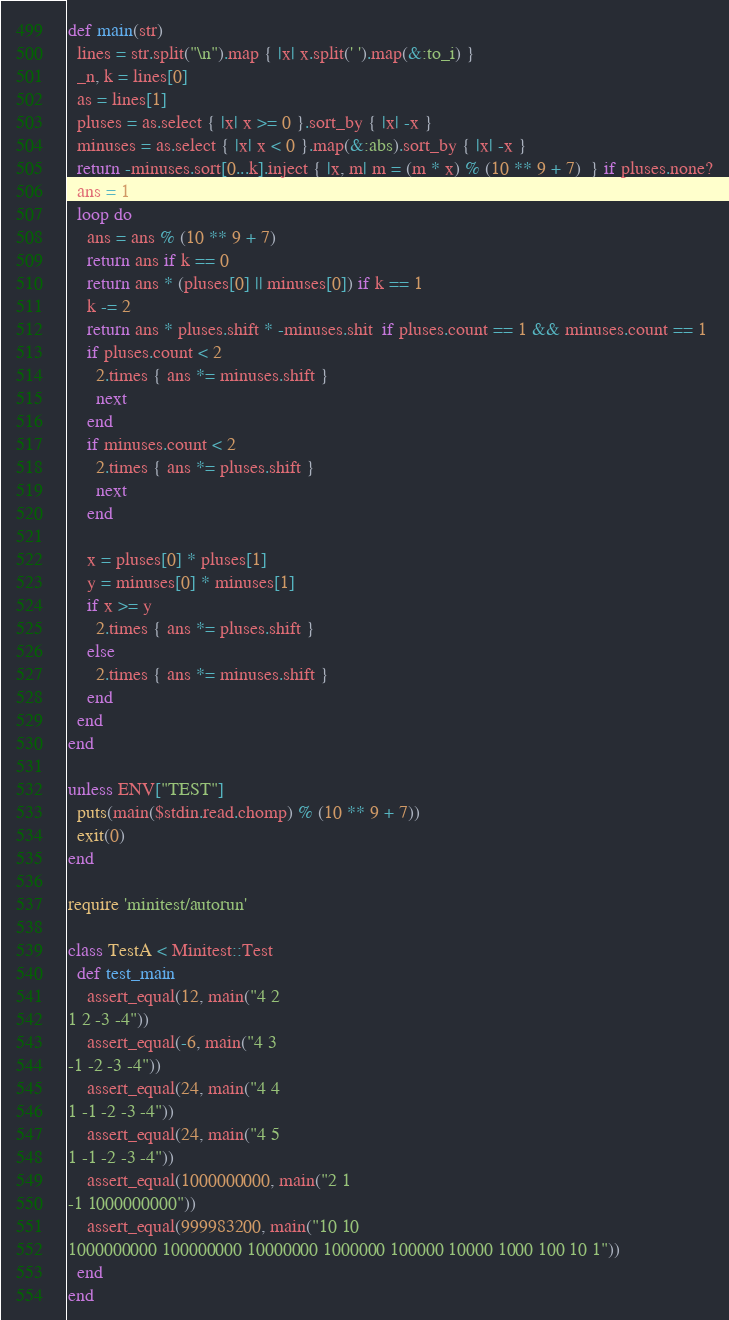Convert code to text. <code><loc_0><loc_0><loc_500><loc_500><_Ruby_>def main(str)
  lines = str.split("\n").map { |x| x.split(' ').map(&:to_i) }
  _n, k = lines[0]
  as = lines[1]
  pluses = as.select { |x| x >= 0 }.sort_by { |x| -x }
  minuses = as.select { |x| x < 0 }.map(&:abs).sort_by { |x| -x }
  return -minuses.sort[0...k].inject { |x, m| m = (m * x) % (10 ** 9 + 7)  } if pluses.none?
  ans = 1
  loop do
    ans = ans % (10 ** 9 + 7)
    return ans if k == 0
    return ans * (pluses[0] || minuses[0]) if k == 1
    k -= 2
    return ans * pluses.shift * -minuses.shit  if pluses.count == 1 && minuses.count == 1
    if pluses.count < 2
      2.times { ans *= minuses.shift }
      next
    end
    if minuses.count < 2
      2.times { ans *= pluses.shift }
      next
    end
    
    x = pluses[0] * pluses[1]
    y = minuses[0] * minuses[1]
    if x >= y
      2.times { ans *= pluses.shift }
    else
      2.times { ans *= minuses.shift }
    end
  end
end

unless ENV["TEST"]
  puts(main($stdin.read.chomp) % (10 ** 9 + 7))
  exit(0)
end

require 'minitest/autorun'

class TestA < Minitest::Test
  def test_main
    assert_equal(12, main("4 2
1 2 -3 -4"))
    assert_equal(-6, main("4 3
-1 -2 -3 -4"))
    assert_equal(24, main("4 4
1 -1 -2 -3 -4"))
    assert_equal(24, main("4 5
1 -1 -2 -3 -4"))
    assert_equal(1000000000, main("2 1
-1 1000000000"))
    assert_equal(999983200, main("10 10
1000000000 100000000 10000000 1000000 100000 10000 1000 100 10 1"))
  end
end


</code> 